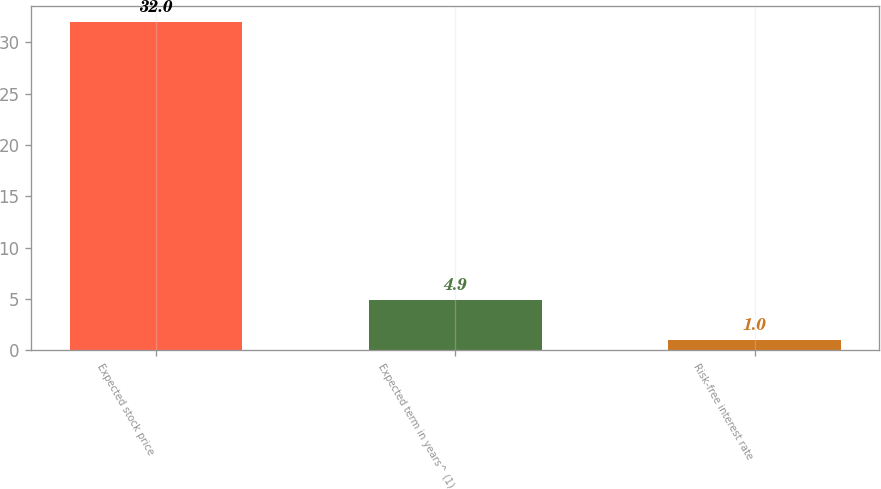<chart> <loc_0><loc_0><loc_500><loc_500><bar_chart><fcel>Expected stock price<fcel>Expected term in years^ (1)<fcel>Risk-free interest rate<nl><fcel>32<fcel>4.9<fcel>1<nl></chart> 